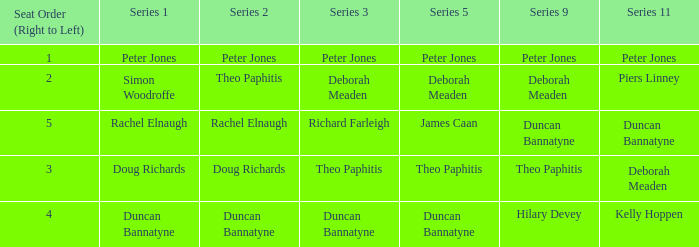How many Seat Orders (Right to Left) have a Series 3 of deborah meaden? 1.0. 